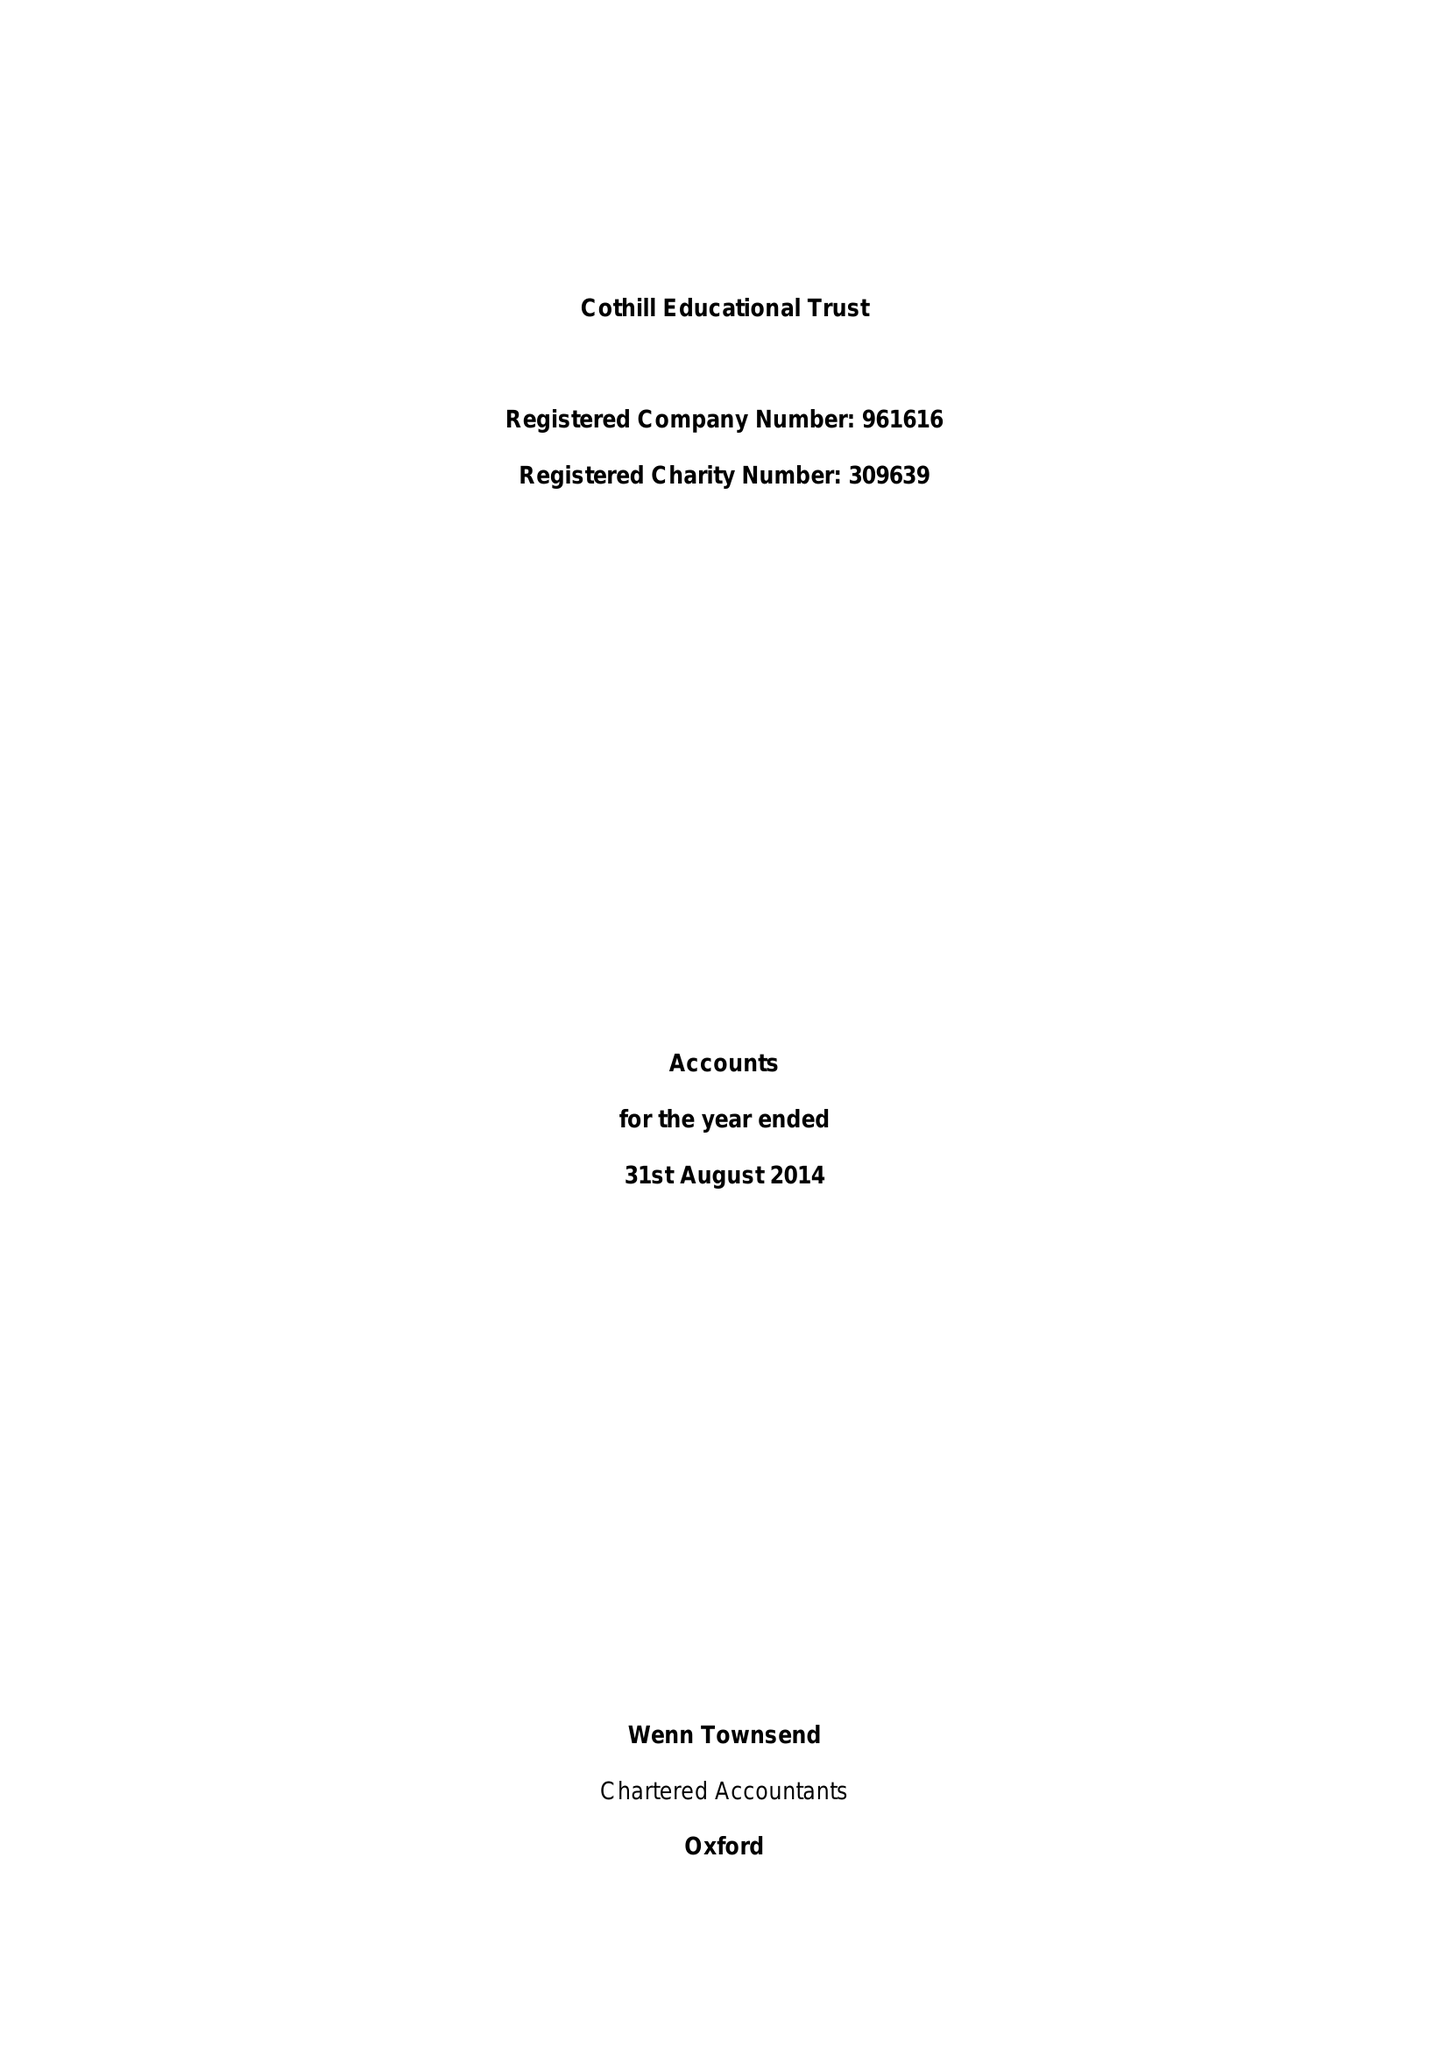What is the value for the charity_name?
Answer the question using a single word or phrase. Cothill Trust 